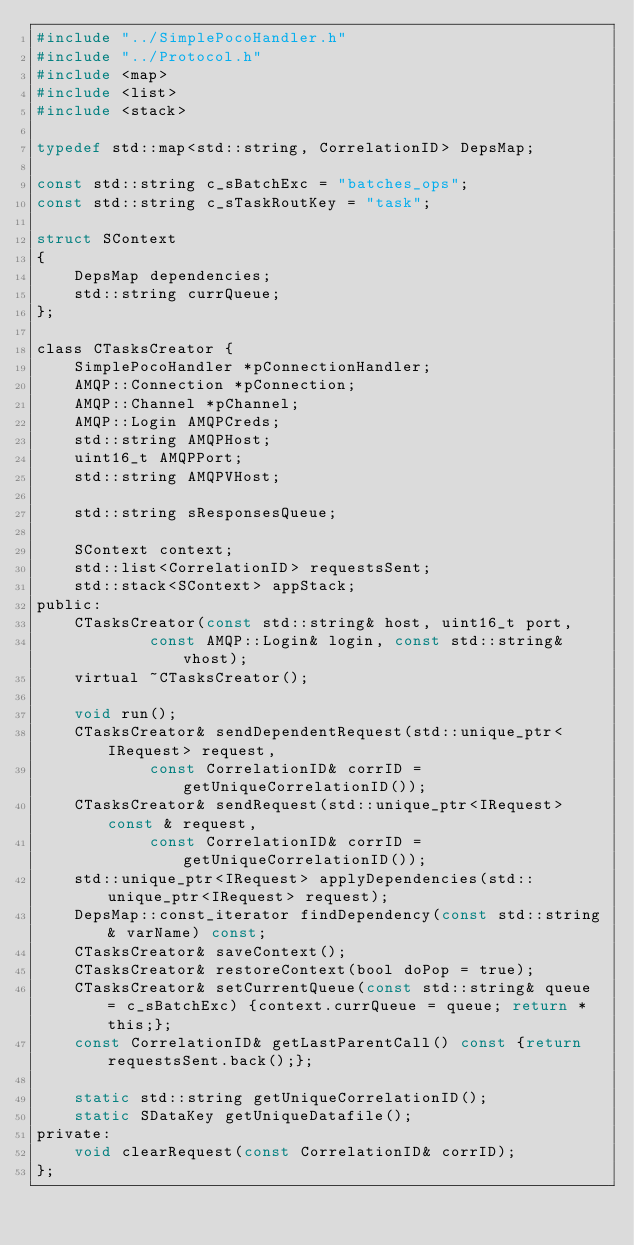Convert code to text. <code><loc_0><loc_0><loc_500><loc_500><_C_>#include "../SimplePocoHandler.h"
#include "../Protocol.h"
#include <map>
#include <list>
#include <stack>

typedef std::map<std::string, CorrelationID> DepsMap;

const std::string c_sBatchExc = "batches_ops";
const std::string c_sTaskRoutKey = "task";

struct SContext
{
	DepsMap dependencies;
	std::string currQueue;
};

class CTasksCreator {
	SimplePocoHandler *pConnectionHandler;
	AMQP::Connection *pConnection;
	AMQP::Channel *pChannel;
	AMQP::Login AMQPCreds;
	std::string AMQPHost;
	uint16_t AMQPPort;
	std::string AMQPVHost;

	std::string sResponsesQueue;

	SContext context;
	std::list<CorrelationID> requestsSent;
	std::stack<SContext> appStack;
public:
	CTasksCreator(const std::string& host, uint16_t port,
			const AMQP::Login& login, const std::string& vhost);
	virtual ~CTasksCreator();

	void run();
	CTasksCreator& sendDependentRequest(std::unique_ptr<IRequest> request,
			const CorrelationID& corrID = getUniqueCorrelationID());
	CTasksCreator& sendRequest(std::unique_ptr<IRequest> const & request,
			const CorrelationID& corrID = getUniqueCorrelationID());
	std::unique_ptr<IRequest> applyDependencies(std::unique_ptr<IRequest> request);
	DepsMap::const_iterator findDependency(const std::string& varName) const;
	CTasksCreator& saveContext();
	CTasksCreator& restoreContext(bool doPop = true);
	CTasksCreator& setCurrentQueue(const std::string& queue = c_sBatchExc) {context.currQueue = queue; return *this;};
	const CorrelationID& getLastParentCall() const {return requestsSent.back();};

	static std::string getUniqueCorrelationID();
	static SDataKey getUniqueDatafile();
private:
	void clearRequest(const CorrelationID& corrID);
};
</code> 